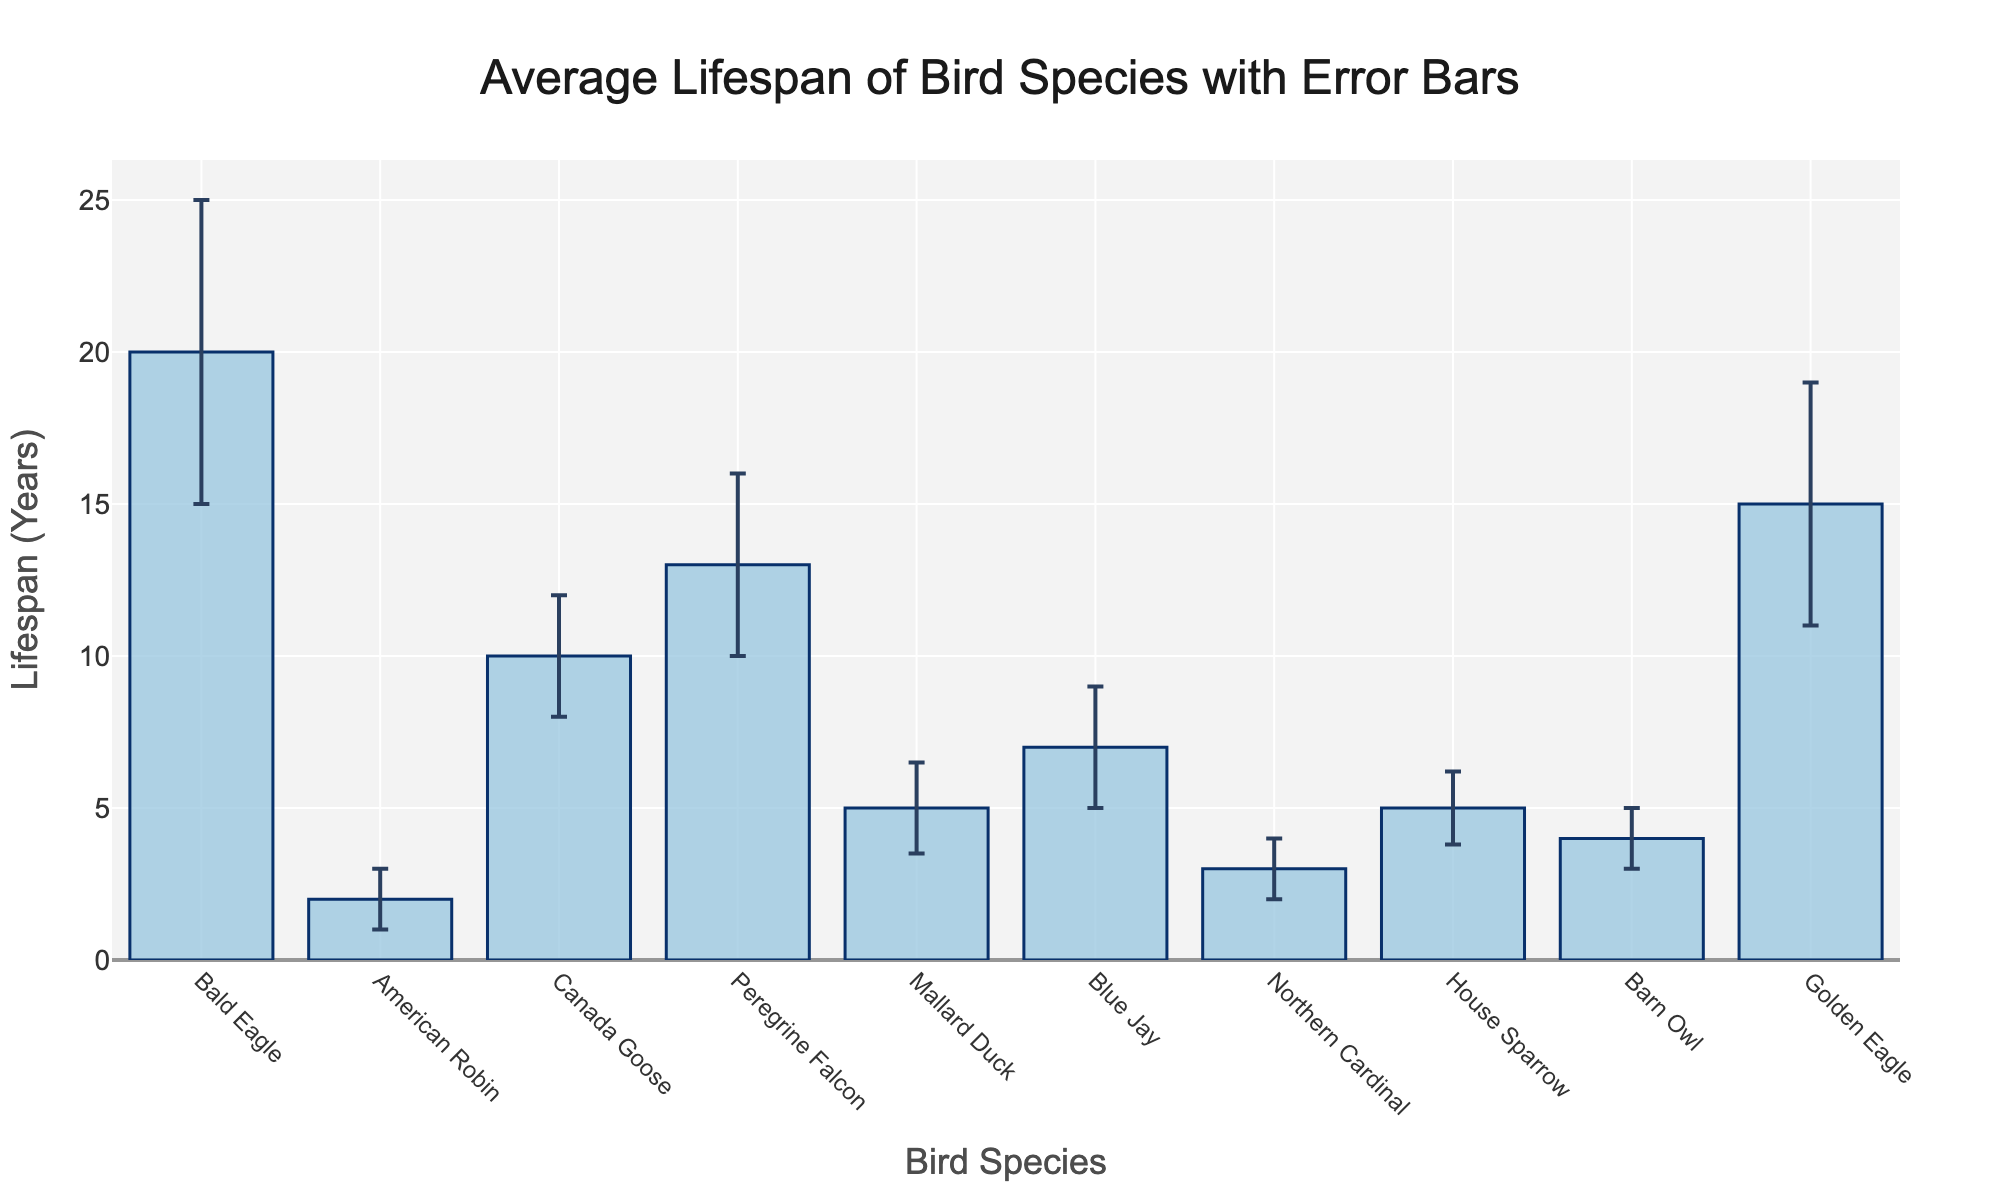Which bird species has the longest average lifespan? The bird species with the longest average lifespan can be identified by looking at the highest bar in the plot.
Answer: Bald Eagle Which bird species has the shortest average lifespan? The bird species with the shortest average lifespan can be identified by looking at the lowest bar in the plot.
Answer: American Robin What is the average lifespan of the Golden Eagle? Look at the bar corresponding to the Golden Eagle in the plot.
Answer: 15 years What is the range of average lifespans shown in the plot? The range can be calculated by subtracting the lifespan of the shortest-lived species from the lifespan of the longest-lived species. Bald Eagle (20 years) - American Robin (2 years).
Answer: 18 years How much does the standard deviation of the Bald Eagle compare to the American Robin? Check the error bars representing the standard deviations. Bald Eagle has a standard deviation of 5, while American Robin has a standard deviation of 1. The difference is 5 - 1.
Answer: 4 Which two bird species have the closest average lifespans? Compare the heights of the bars to find the ones that are closest to each other in height.
Answer: House Sparrow and Mallard Duck How does the standard deviation of the Golden Eagle compare to the Peregrine Falcon? Look at the error bars for these two bird species. Golden Eagle has a standard deviation of 4, while Peregrine Falcon has a standard deviation of 3.
Answer: 1 more for Golden Eagle What is the total average lifespan of all the bird species combined? Add the average lifespans of all bird species: 20 + 2 + 10 + 13 + 5 + 7 + 3 + 5 + 4 + 15.
Answer: 84 years Considering standard deviations, which bird species has the most variability in lifespan? The bird species with the largest error bar indicates the highest variability in lifespan.
Answer: Bald Eagle Which bird species has an average lifespan that falls in the middle of the range? An average (median) lifespan value needs to be found. Sort the species by lifespan: American Robin (2), Northern Cardinal (3), Barn Owl (4), House Sparrow (5), Mallard Duck (5), Blue Jay (7), Canada Goose (10), Peregrine Falcon (13), Golden Eagle (15), Bald Eagle (20). The middle lifespan value is the average of th listed 10 average lifespans, so the median lifespan values are between Blue Jay (7) and Canada Goose (10)
Answer: Blue Jay and Canada Goose 